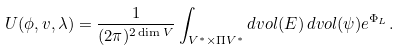Convert formula to latex. <formula><loc_0><loc_0><loc_500><loc_500>U ( \phi , v , \lambda ) = \frac { 1 } { ( 2 \pi ) ^ { 2 \dim V } } \int _ { V ^ { * } \times \Pi V ^ { * } } d v o l ( E ) \, d v o l ( \psi ) e ^ { \Phi _ { L } } .</formula> 